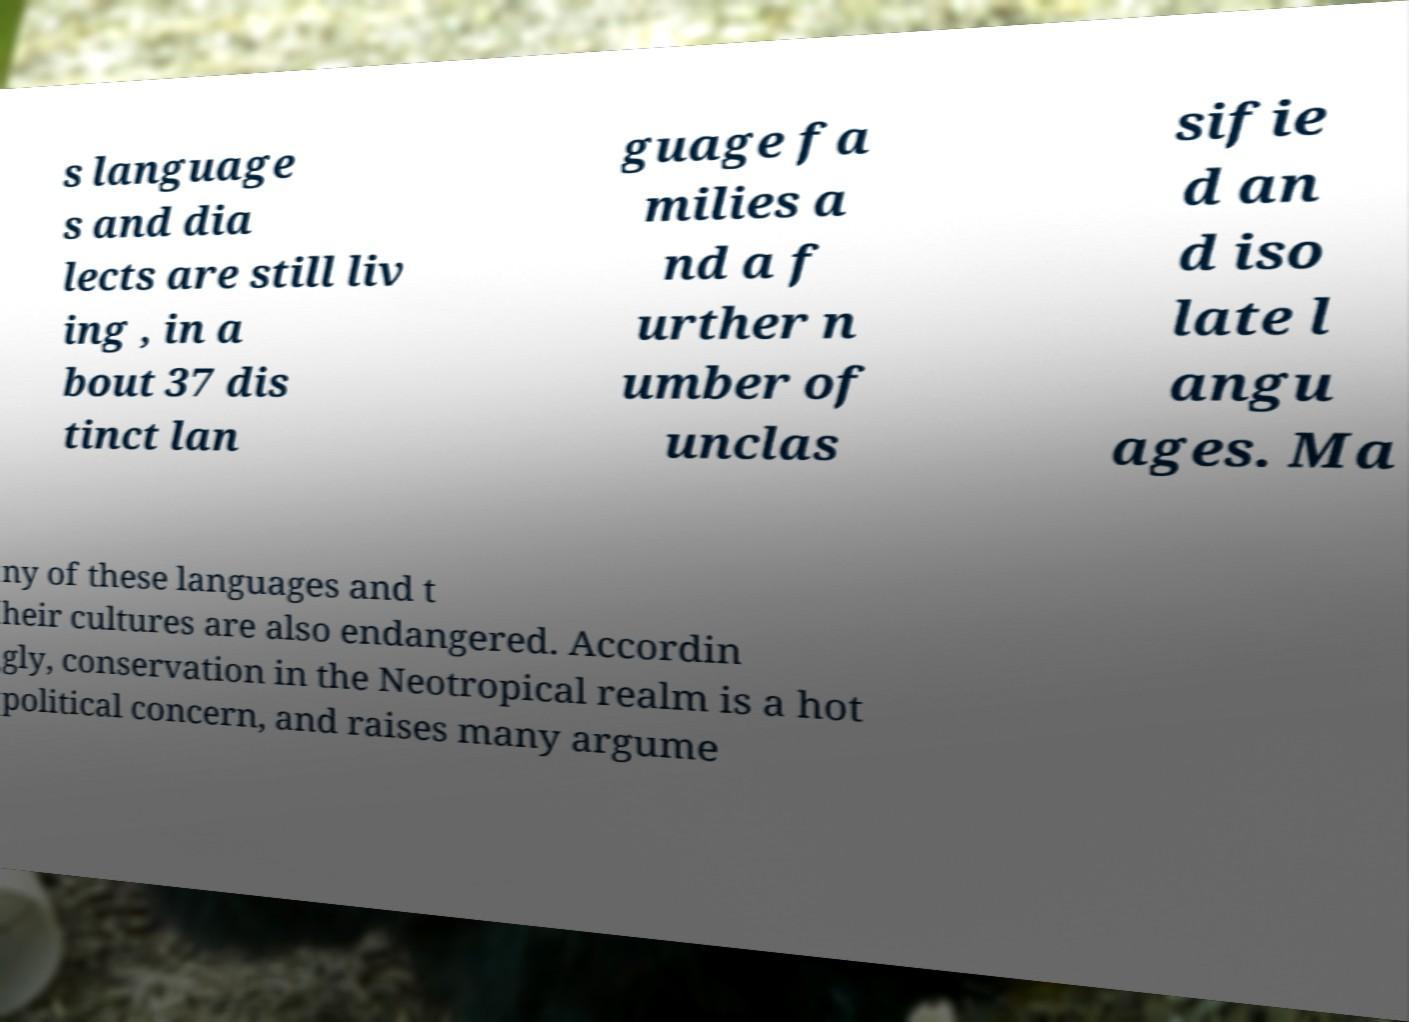Could you extract and type out the text from this image? s language s and dia lects are still liv ing , in a bout 37 dis tinct lan guage fa milies a nd a f urther n umber of unclas sifie d an d iso late l angu ages. Ma ny of these languages and t heir cultures are also endangered. Accordin gly, conservation in the Neotropical realm is a hot political concern, and raises many argume 